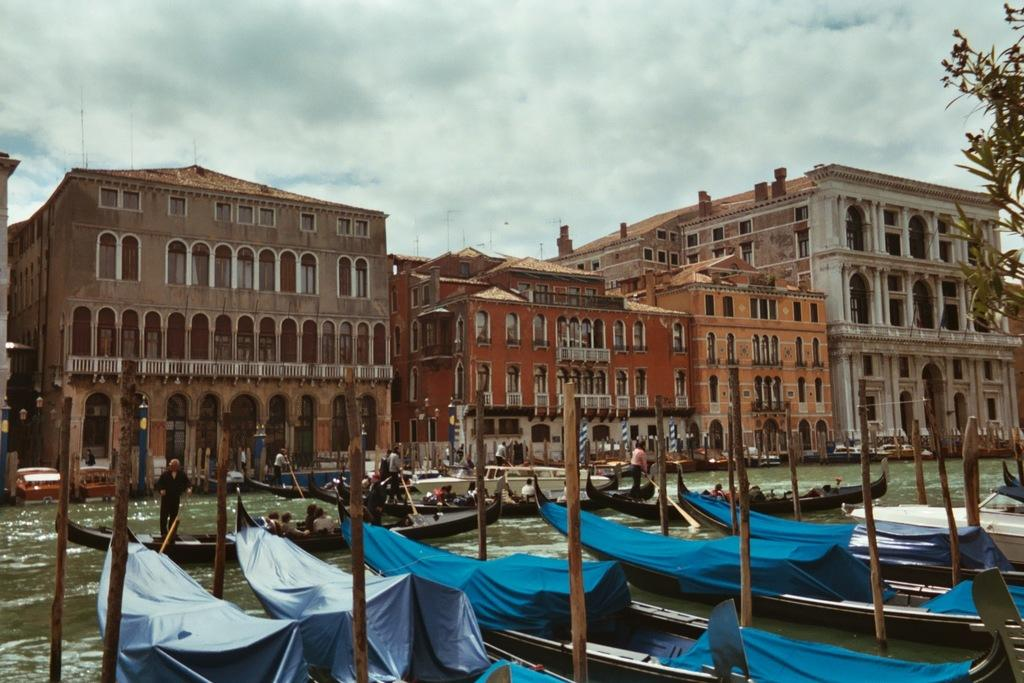What type of structures are visible in the image? There are tall buildings in the image. What natural feature is present in front of the buildings? There is a river in front of the buildings. Are there any objects or vehicles on the river? Yes, there are boats on the river. What color is the brain of the person in the image? There is no person or brain present in the image; it features tall buildings, a river, and boats. 